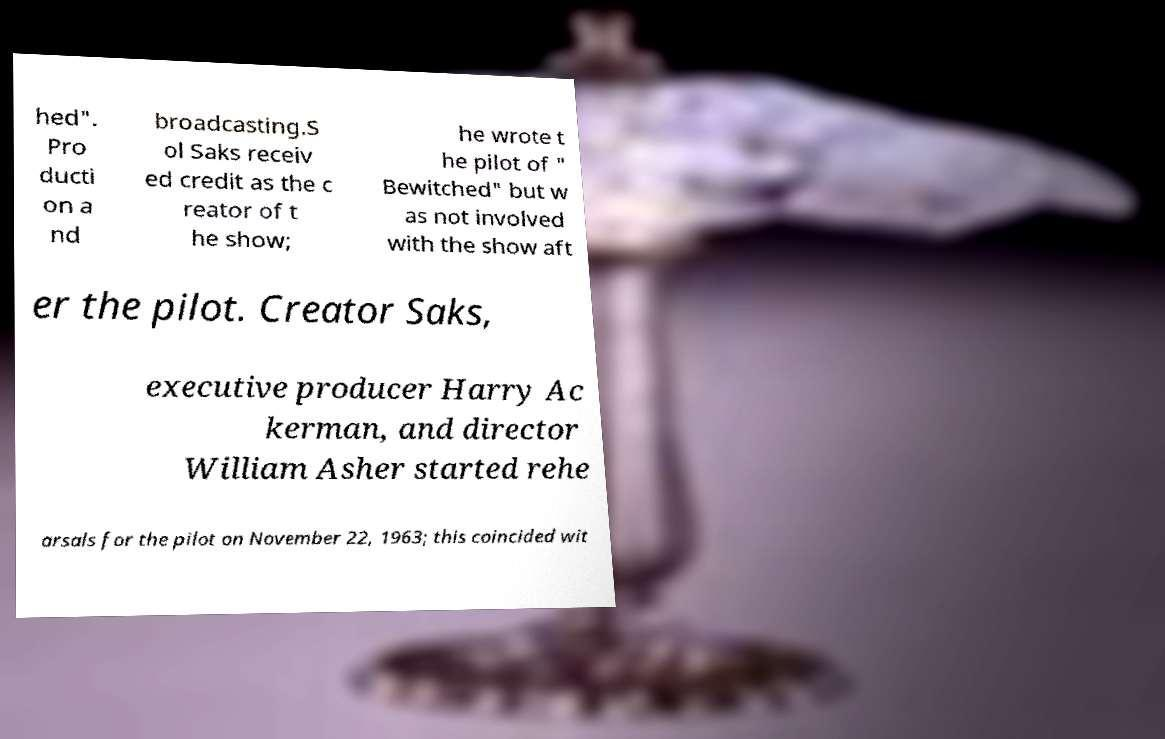Please read and relay the text visible in this image. What does it say? hed". Pro ducti on a nd broadcasting.S ol Saks receiv ed credit as the c reator of t he show; he wrote t he pilot of " Bewitched" but w as not involved with the show aft er the pilot. Creator Saks, executive producer Harry Ac kerman, and director William Asher started rehe arsals for the pilot on November 22, 1963; this coincided wit 